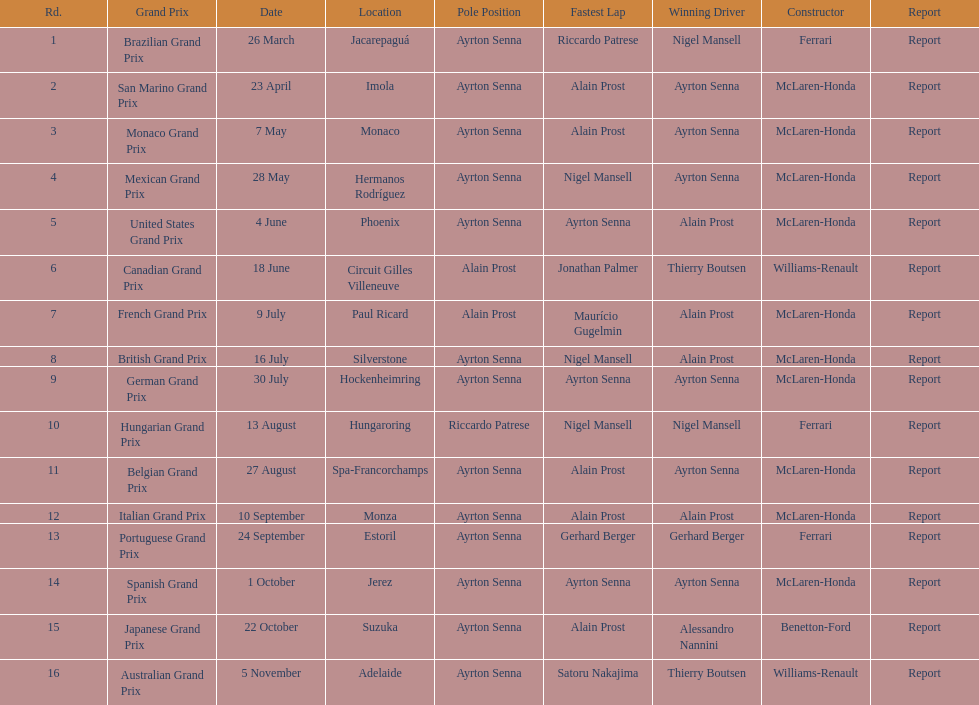How many times was ayrton senna in pole position? 13. 